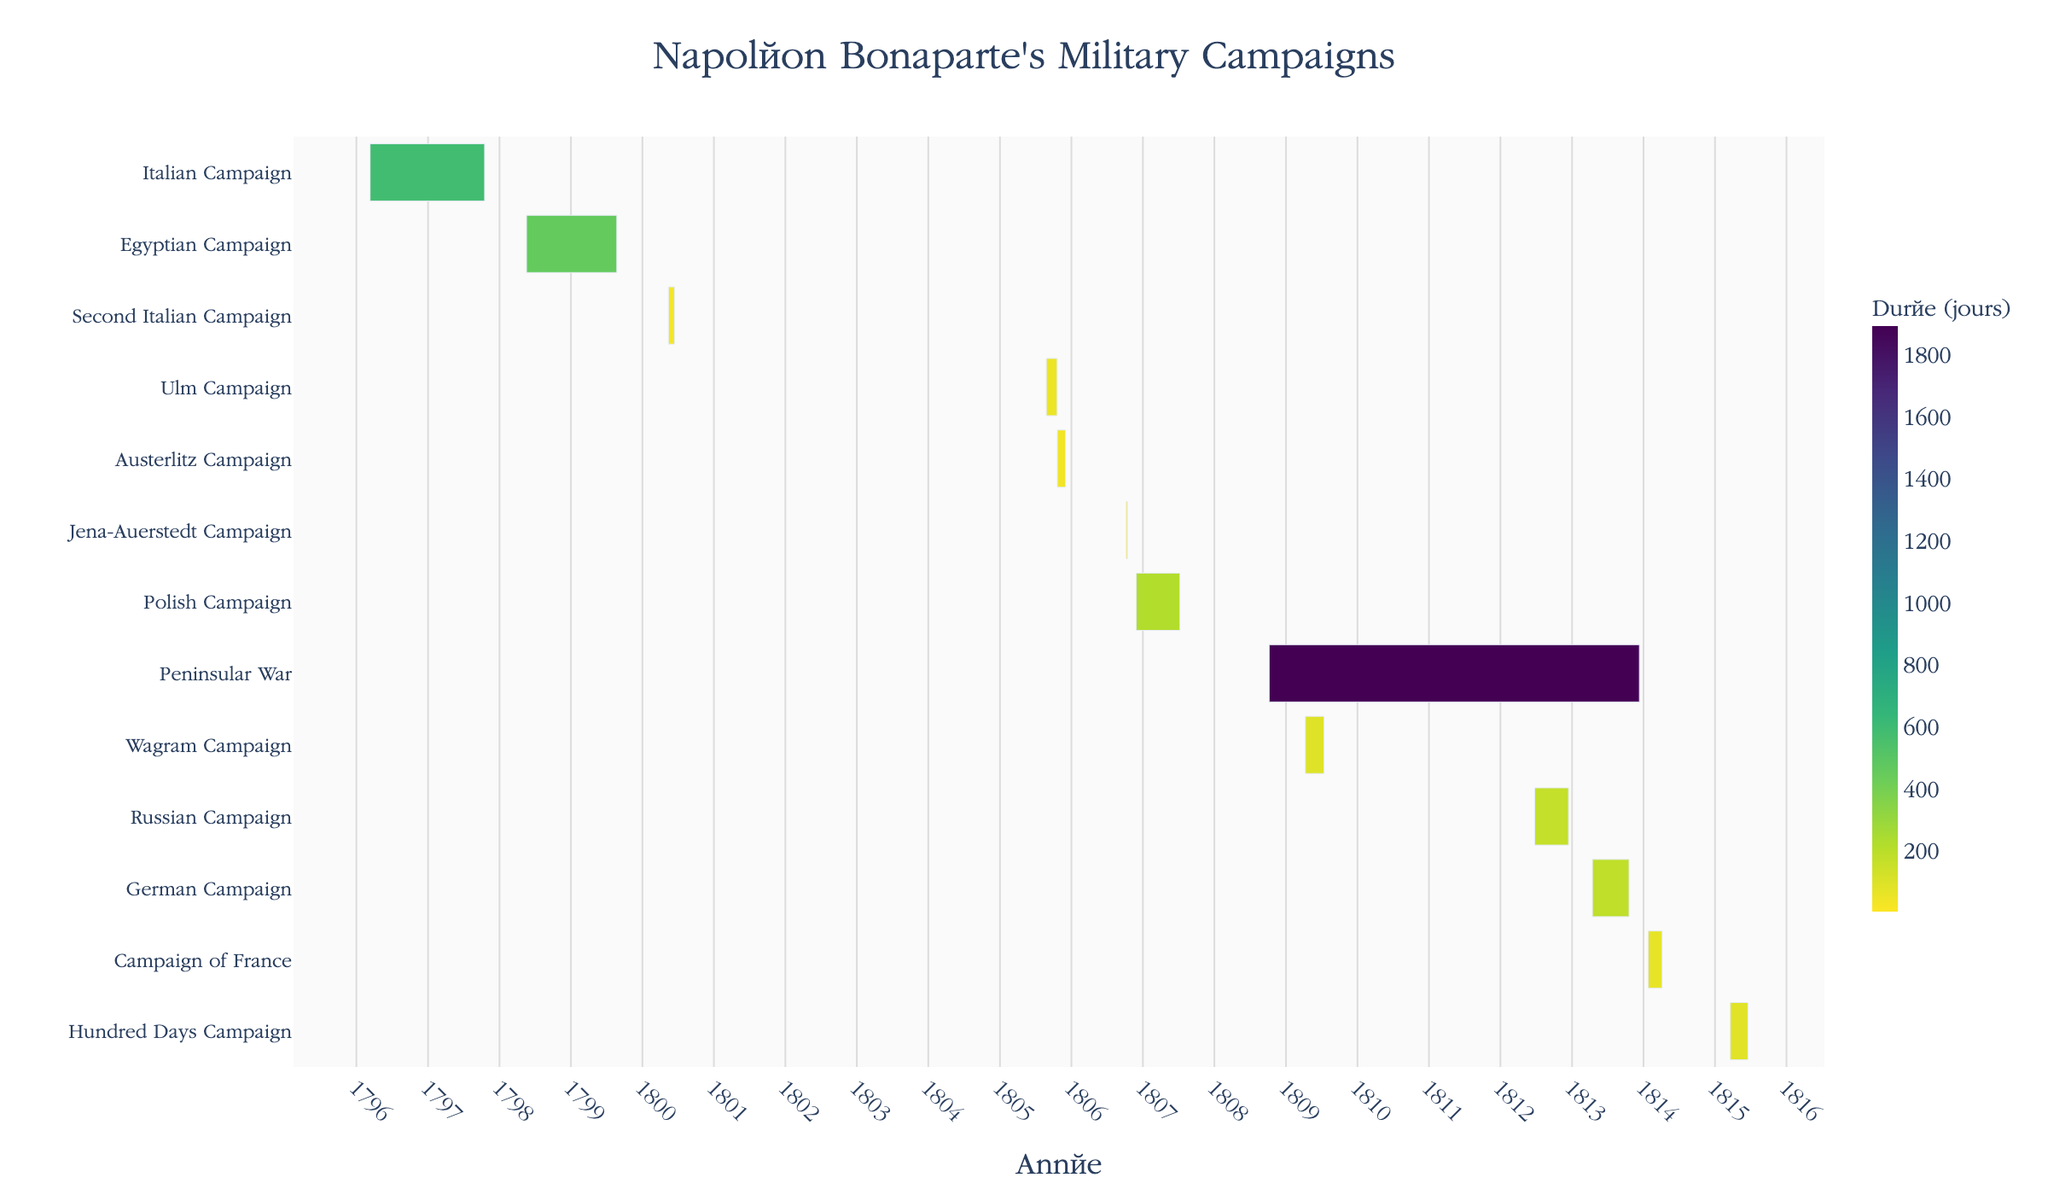What is the title of the Gantt chart? The title of the Gantt chart is found at the top of the chart and usually summarizes the entire content or purpose of the chart. Here it should succinctly denote what the figure is about.
Answer: Napoléon Bonaparte's Military Campaigns Which Napoléon's campaign lasted the longest? Looking at the Gantt chart, find the campaign bar that stretches the farthest across the x-axis, indicating the start and end dates are the furthest apart.
Answer: Peninsular War What is the duration of the Egyptian Campaign? Hovering over the bar for the Egyptian Campaign, the hover information will display the duration directly.
Answer: 462 days Which campaigns occurred in the year 1805? Identify the campaigns that have bars overlapping with the year 1805. Check the start and end dates for accuracy.
Answer: Ulm Campaign, Austerlitz Campaign What is the sum of the durations of the Wagram Campaign and the Russian Campaign? First, find the individual durations from the chart's hover information. Then, add these durations together to get the total.
Answer: Total: 96 + 173 = 269 days Between the First Italian Campaign and the Second Italian Campaign, which had a shorter duration? Compare the two campaign durations as indicated by the visual bar lengths or hover information. The campaign with the shorter bar had a shorter duration.
Answer: Second Italian Campaign How many campaigns overlapped with the Peninsular War? Look for other campaign bars that intersect with the start and end dates of the Peninsular War. Count these bars.
Answer: 3 (Wagram Campaign, Russian Campaign, German Campaign) In which year does the Gantt chart end? The chart's x-axis should help identify the latest end date for any campaign displayed in the figure.
Answer: 1815 What can you infer about the intensity of Napoléon's campaigns during 1806-1807? Count the number of campaigns and observe their durations within the specified years to deduce the level of military activity.
Answer: High intensity, with Jena-Auerstedt Campaign, Polish Campaign Which campaign followed directly after the Italian Campaign of 1796-1797 based on the timeline? Look to the timeline to identify the campaign that starts soonest after the end date of the Italian Campaign of 1796-1797.
Answer: Egyptian Campaign 